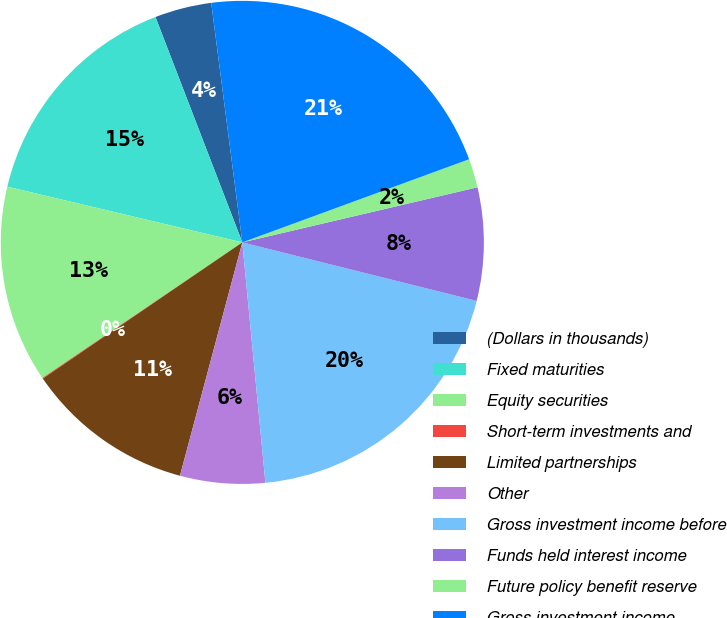Convert chart to OTSL. <chart><loc_0><loc_0><loc_500><loc_500><pie_chart><fcel>(Dollars in thousands)<fcel>Fixed maturities<fcel>Equity securities<fcel>Short-term investments and<fcel>Limited partnerships<fcel>Other<fcel>Gross investment income before<fcel>Funds held interest income<fcel>Future policy benefit reserve<fcel>Gross investment income<nl><fcel>3.8%<fcel>15.44%<fcel>13.19%<fcel>0.05%<fcel>11.31%<fcel>5.68%<fcel>19.58%<fcel>7.56%<fcel>1.93%<fcel>21.46%<nl></chart> 